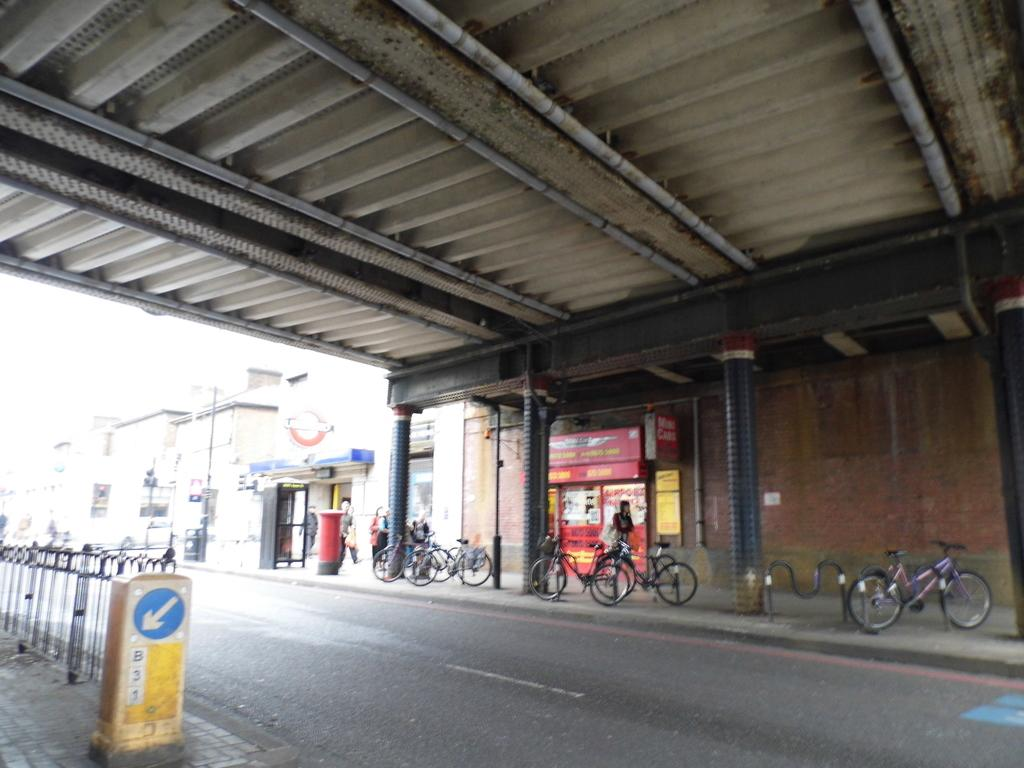What is the main feature of the image? There is a road in the image. Can you describe the people in the image? There are people in the image. What type of vehicles can be seen in the image? Bicycles are present in the image. What architectural elements are visible in the image? There are pillars, a wall, and a roof in the image. What else can be seen in the image? There are some objects and buildings in the background of the image. Can you tell me how many docks are visible in the image? There are no docks present in the image. What type of sea creatures can be seen swimming near the people in the image? There are no sea creatures visible in the image. 